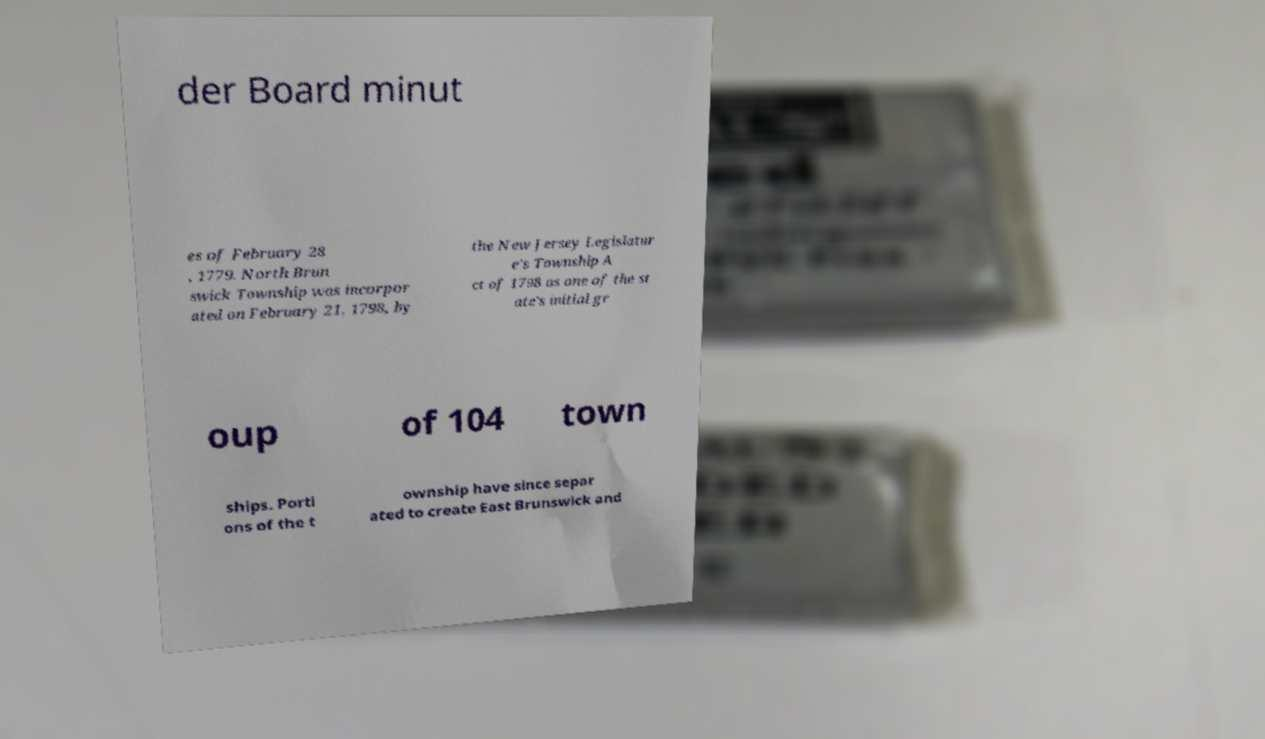Can you read and provide the text displayed in the image?This photo seems to have some interesting text. Can you extract and type it out for me? der Board minut es of February 28 , 1779. North Brun swick Township was incorpor ated on February 21, 1798, by the New Jersey Legislatur e's Township A ct of 1798 as one of the st ate's initial gr oup of 104 town ships. Porti ons of the t ownship have since separ ated to create East Brunswick and 